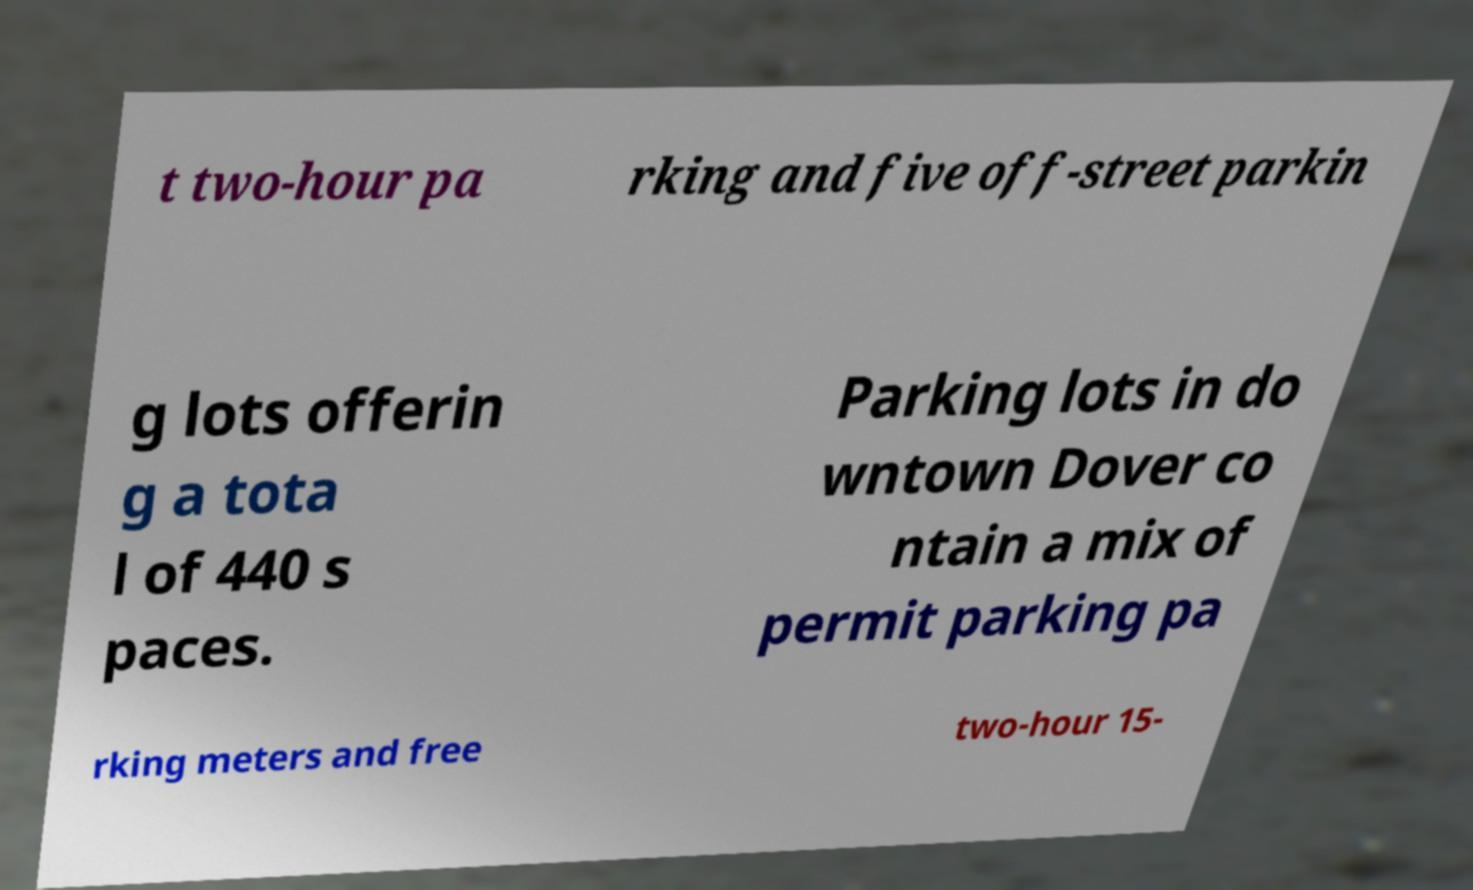Please read and relay the text visible in this image. What does it say? t two-hour pa rking and five off-street parkin g lots offerin g a tota l of 440 s paces. Parking lots in do wntown Dover co ntain a mix of permit parking pa rking meters and free two-hour 15- 